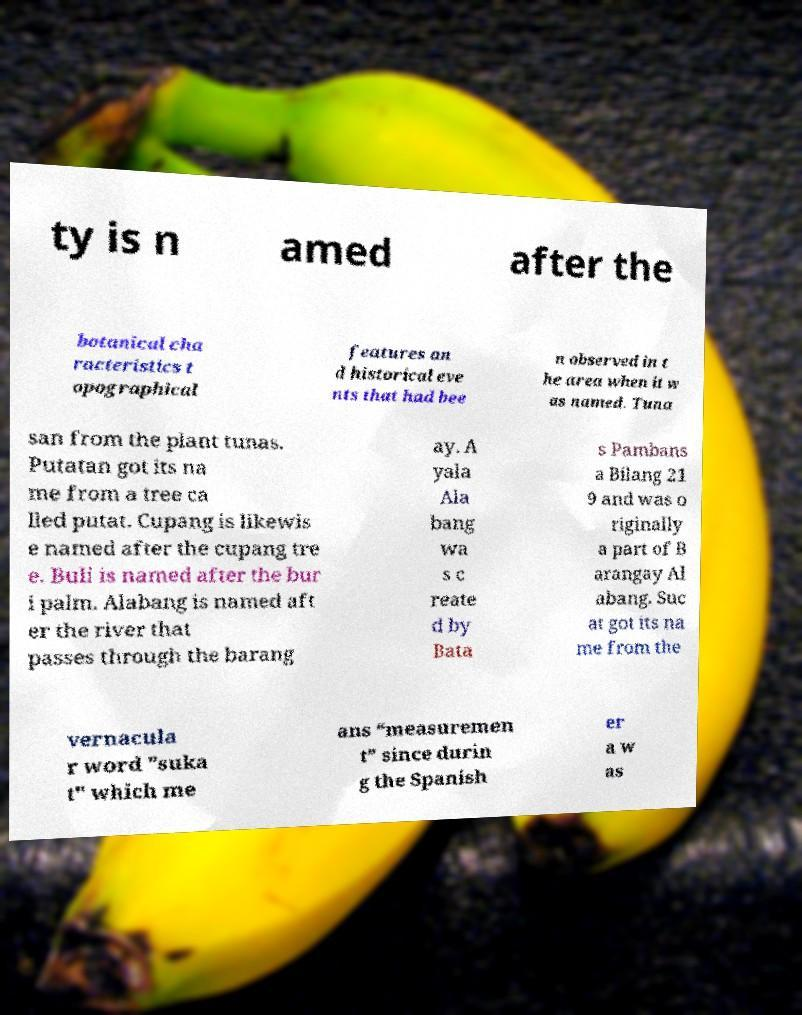Could you extract and type out the text from this image? ty is n amed after the botanical cha racteristics t opographical features an d historical eve nts that had bee n observed in t he area when it w as named. Tuna san from the plant tunas. Putatan got its na me from a tree ca lled putat. Cupang is likewis e named after the cupang tre e. Buli is named after the bur i palm. Alabang is named aft er the river that passes through the barang ay. A yala Ala bang wa s c reate d by Bata s Pambans a Bilang 21 9 and was o riginally a part of B arangay Al abang. Suc at got its na me from the vernacula r word "suka t" which me ans “measuremen t” since durin g the Spanish er a w as 